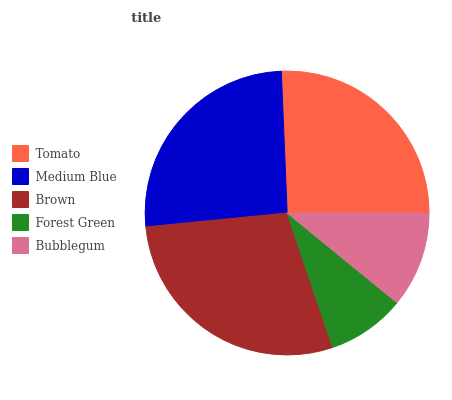Is Forest Green the minimum?
Answer yes or no. Yes. Is Brown the maximum?
Answer yes or no. Yes. Is Medium Blue the minimum?
Answer yes or no. No. Is Medium Blue the maximum?
Answer yes or no. No. Is Medium Blue greater than Tomato?
Answer yes or no. Yes. Is Tomato less than Medium Blue?
Answer yes or no. Yes. Is Tomato greater than Medium Blue?
Answer yes or no. No. Is Medium Blue less than Tomato?
Answer yes or no. No. Is Tomato the high median?
Answer yes or no. Yes. Is Tomato the low median?
Answer yes or no. Yes. Is Forest Green the high median?
Answer yes or no. No. Is Brown the low median?
Answer yes or no. No. 